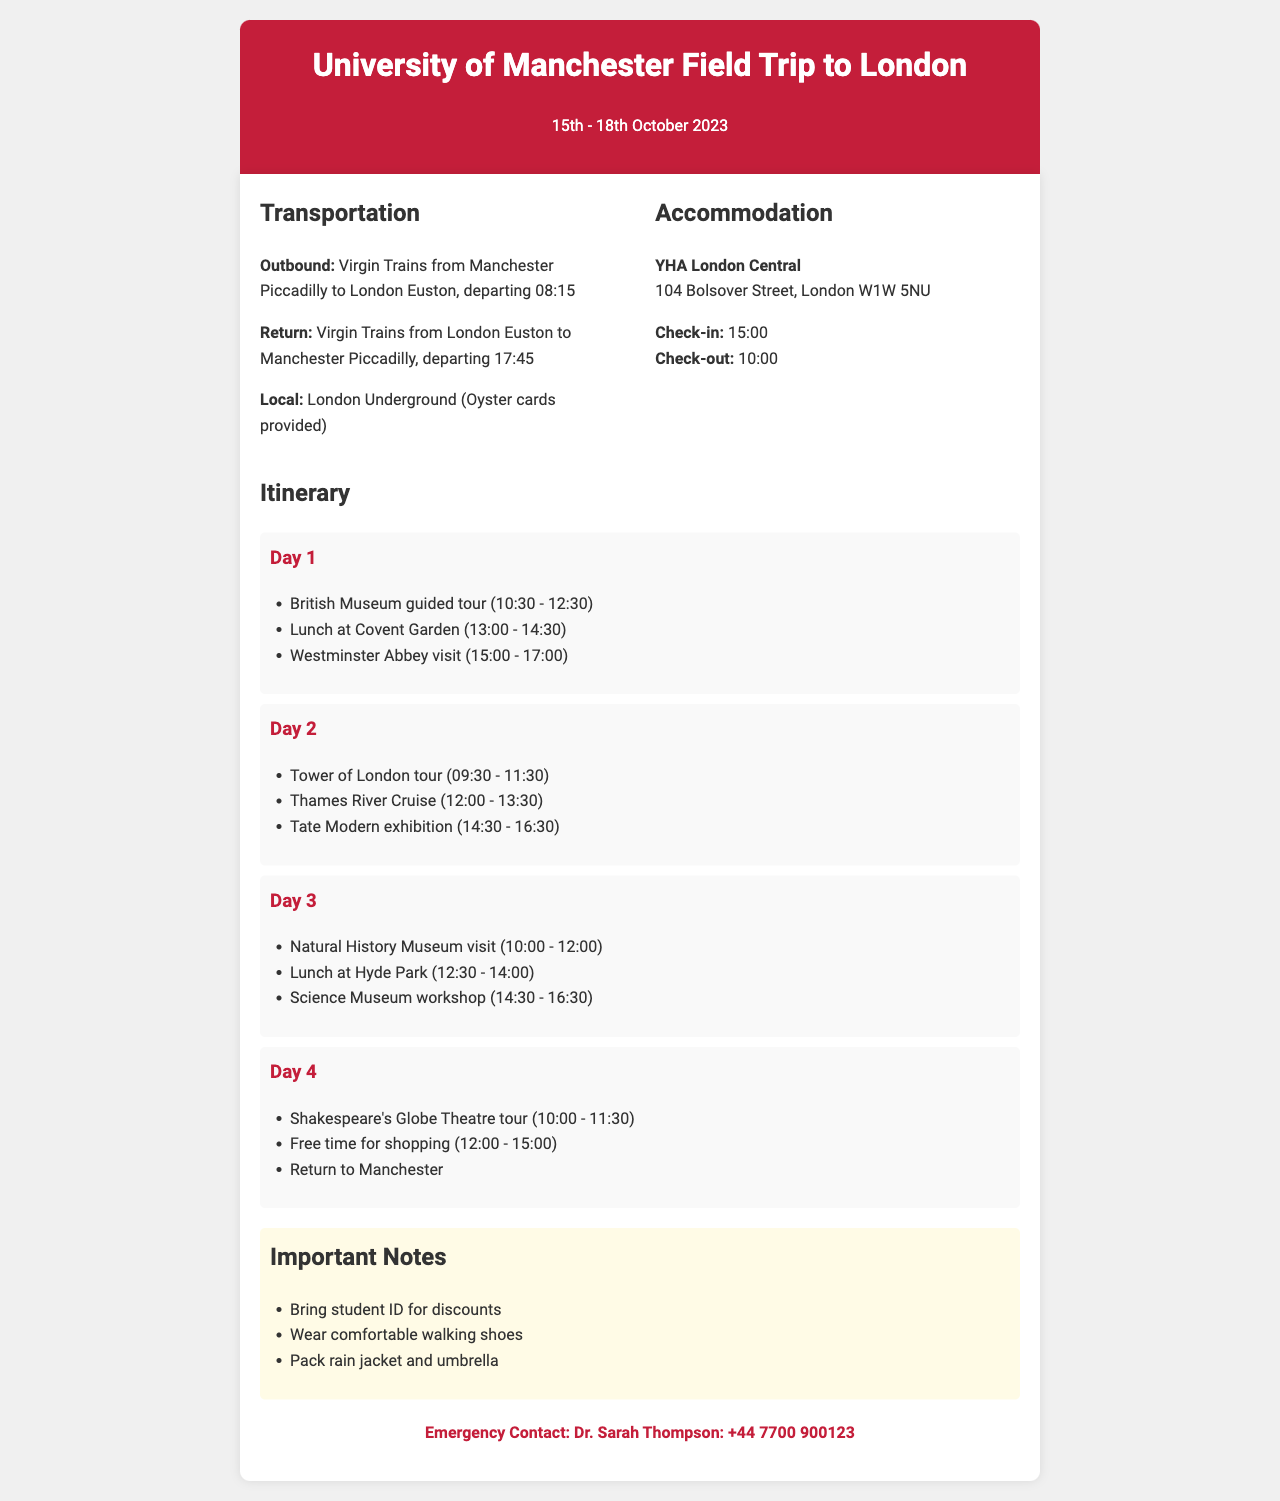What are the dates of the trip? The dates of the trip are specified in the header of the document as "15th - 18th October 2023".
Answer: 15th - 18th October 2023 What time does the outbound train leave? The outbound train departure time is mentioned in the transportation section as "08:15".
Answer: 08:15 What is the accommodation name? The name of the accommodation is stated in the document under the accommodation section as "YHA London Central".
Answer: YHA London Central How long is the visit to Westminster Abbey? The duration of the visit to Westminster Abbey is indicated in the itinerary for Day 1 as "2 hours".
Answer: 2 hours What should you bring for discounts? The important note mentions the need to bring a "student ID" for discounts.
Answer: student ID What is the emergency contact number? The emergency contact number is listed in the emergency section at the end of the document as "+44 7700 900123".
Answer: +44 7700 900123 Which day has an activity at the Natural History Museum? The itinerary specifies that the activity at the Natural History Museum occurs on "Day 3".
Answer: Day 3 How many activities are scheduled for Day 2? The itinerary for Day 2 lists "3 activities" scheduled, indicating they are "Tower of London tour", "Thames River Cruise", and "Tate Modern exhibition".
Answer: 3 activities What time do students check out of the accommodation? The check-out time for the accommodation is provided under the accommodation section as "10:00".
Answer: 10:00 